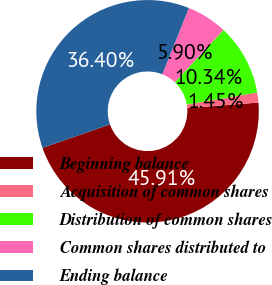Convert chart. <chart><loc_0><loc_0><loc_500><loc_500><pie_chart><fcel>Beginning balance<fcel>Acquisition of common shares<fcel>Distribution of common shares<fcel>Common shares distributed to<fcel>Ending balance<nl><fcel>45.91%<fcel>1.45%<fcel>10.34%<fcel>5.9%<fcel>36.4%<nl></chart> 